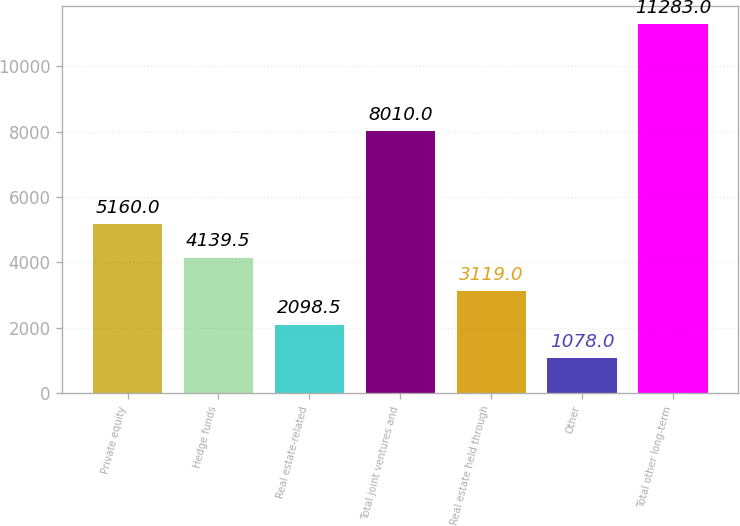Convert chart to OTSL. <chart><loc_0><loc_0><loc_500><loc_500><bar_chart><fcel>Private equity<fcel>Hedge funds<fcel>Real estate-related<fcel>Total joint ventures and<fcel>Real estate held through<fcel>Other<fcel>Total other long-term<nl><fcel>5160<fcel>4139.5<fcel>2098.5<fcel>8010<fcel>3119<fcel>1078<fcel>11283<nl></chart> 